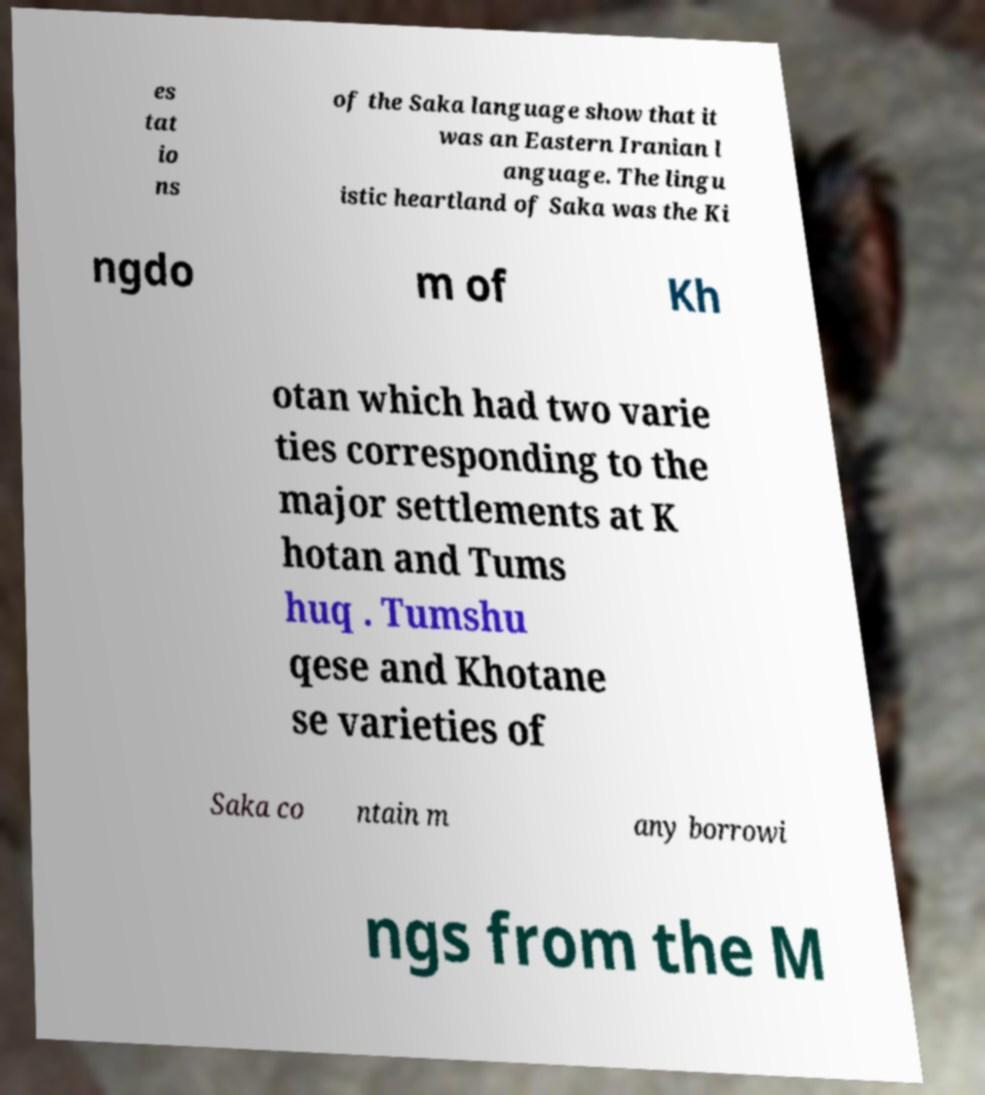Can you accurately transcribe the text from the provided image for me? es tat io ns of the Saka language show that it was an Eastern Iranian l anguage. The lingu istic heartland of Saka was the Ki ngdo m of Kh otan which had two varie ties corresponding to the major settlements at K hotan and Tums huq . Tumshu qese and Khotane se varieties of Saka co ntain m any borrowi ngs from the M 